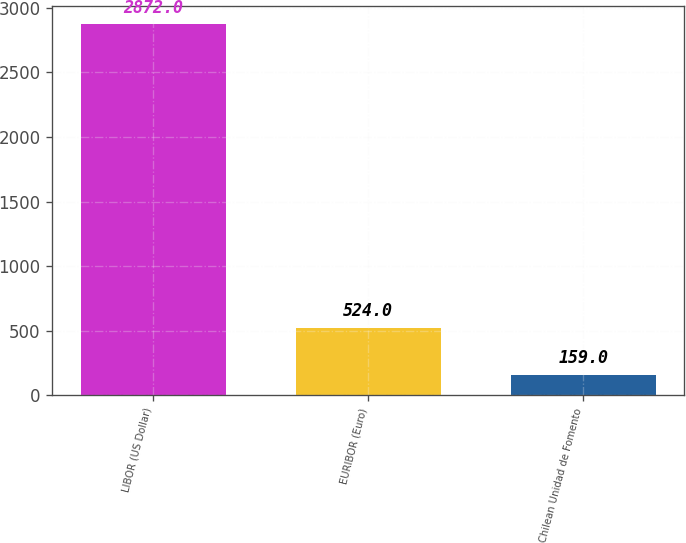<chart> <loc_0><loc_0><loc_500><loc_500><bar_chart><fcel>LIBOR (US Dollar)<fcel>EURIBOR (Euro)<fcel>Chilean Unidad de Fomento<nl><fcel>2872<fcel>524<fcel>159<nl></chart> 